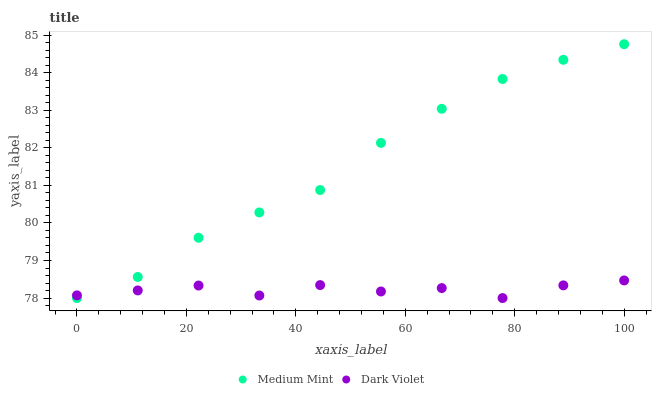Does Dark Violet have the minimum area under the curve?
Answer yes or no. Yes. Does Medium Mint have the maximum area under the curve?
Answer yes or no. Yes. Does Dark Violet have the maximum area under the curve?
Answer yes or no. No. Is Medium Mint the smoothest?
Answer yes or no. Yes. Is Dark Violet the roughest?
Answer yes or no. Yes. Is Dark Violet the smoothest?
Answer yes or no. No. Does Medium Mint have the lowest value?
Answer yes or no. Yes. Does Medium Mint have the highest value?
Answer yes or no. Yes. Does Dark Violet have the highest value?
Answer yes or no. No. Does Dark Violet intersect Medium Mint?
Answer yes or no. Yes. Is Dark Violet less than Medium Mint?
Answer yes or no. No. Is Dark Violet greater than Medium Mint?
Answer yes or no. No. 